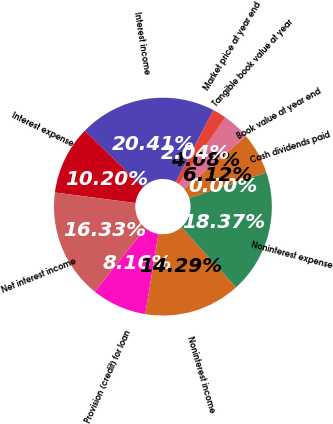<chart> <loc_0><loc_0><loc_500><loc_500><pie_chart><fcel>Interest income<fcel>Interest expense<fcel>Net interest income<fcel>Provision (credit) for loan<fcel>Noninterest income<fcel>Noninterest expense<fcel>Cash dividends paid<fcel>Book value at year end<fcel>Tangible book value at year<fcel>Market price at year end<nl><fcel>20.41%<fcel>10.2%<fcel>16.33%<fcel>8.16%<fcel>14.29%<fcel>18.37%<fcel>0.0%<fcel>6.12%<fcel>4.08%<fcel>2.04%<nl></chart> 